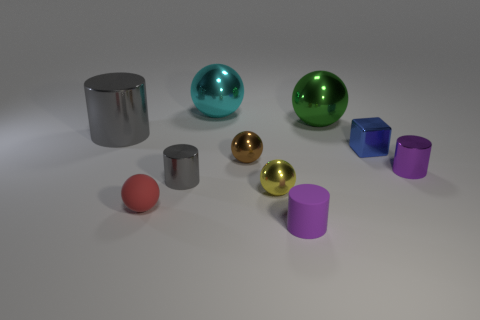How many matte things are tiny red balls or big yellow objects?
Offer a very short reply. 1. Is the shape of the green metal object behind the small brown thing the same as the purple thing that is to the right of the large green metal object?
Give a very brief answer. No. What is the color of the sphere that is both behind the big gray cylinder and right of the big cyan shiny thing?
Your answer should be very brief. Green. Does the yellow thing that is behind the tiny red matte ball have the same size as the rubber thing left of the cyan thing?
Your answer should be compact. Yes. What number of other small rubber spheres are the same color as the tiny rubber sphere?
Keep it short and to the point. 0. What number of tiny objects are cyan metal balls or yellow rubber objects?
Keep it short and to the point. 0. Does the purple cylinder to the right of the small rubber cylinder have the same material as the cyan sphere?
Make the answer very short. Yes. What is the color of the object that is on the right side of the blue block?
Offer a terse response. Purple. Are there any yellow objects that have the same size as the matte sphere?
Offer a terse response. Yes. What material is the blue object that is the same size as the red thing?
Offer a very short reply. Metal. 